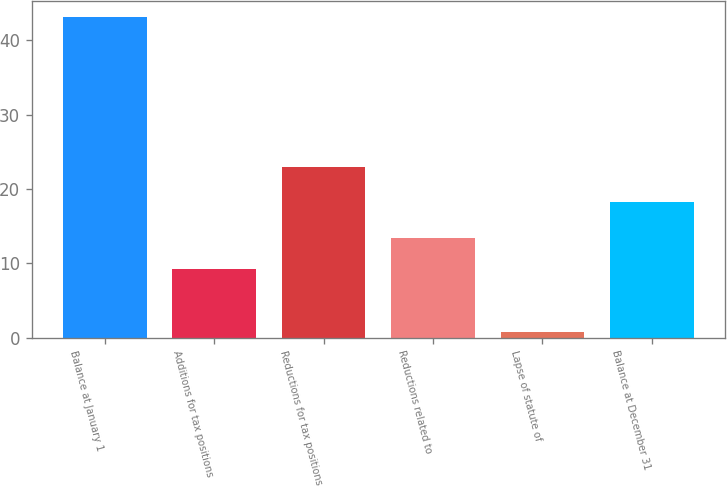Convert chart to OTSL. <chart><loc_0><loc_0><loc_500><loc_500><bar_chart><fcel>Balance at January 1<fcel>Additions for tax positions<fcel>Reductions for tax positions<fcel>Reductions related to<fcel>Lapse of statute of<fcel>Balance at December 31<nl><fcel>43.1<fcel>9.18<fcel>22.9<fcel>13.42<fcel>0.7<fcel>18.3<nl></chart> 